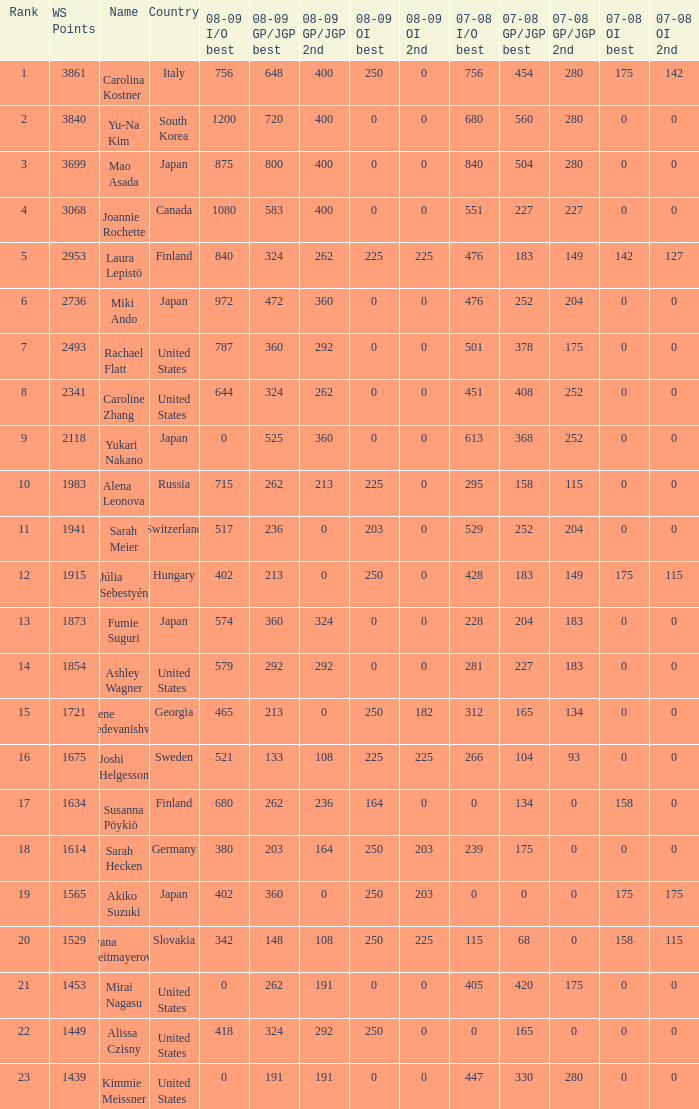08-09 gp/jgp 2nd is 213 and ws points will be what maximum 1983.0. 